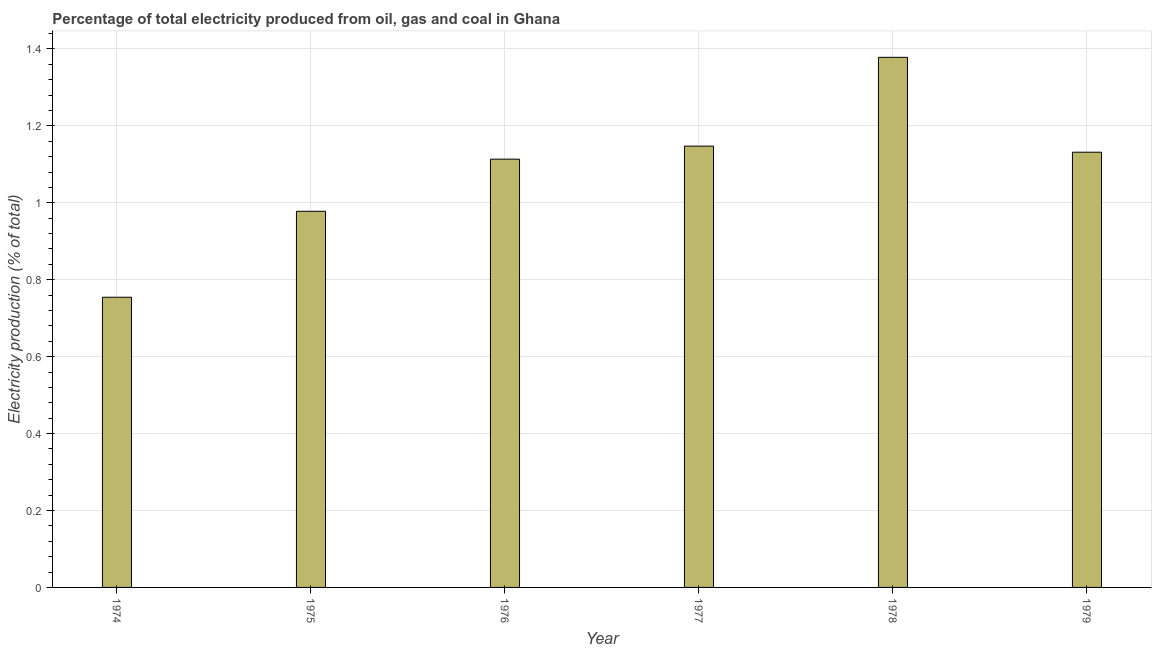What is the title of the graph?
Your response must be concise. Percentage of total electricity produced from oil, gas and coal in Ghana. What is the label or title of the Y-axis?
Your response must be concise. Electricity production (% of total). What is the electricity production in 1979?
Keep it short and to the point. 1.13. Across all years, what is the maximum electricity production?
Provide a short and direct response. 1.38. Across all years, what is the minimum electricity production?
Provide a succinct answer. 0.75. In which year was the electricity production maximum?
Your answer should be very brief. 1978. In which year was the electricity production minimum?
Keep it short and to the point. 1974. What is the sum of the electricity production?
Keep it short and to the point. 6.5. What is the difference between the electricity production in 1975 and 1979?
Give a very brief answer. -0.15. What is the average electricity production per year?
Provide a short and direct response. 1.08. What is the median electricity production?
Provide a succinct answer. 1.12. Do a majority of the years between 1974 and 1979 (inclusive) have electricity production greater than 0.32 %?
Keep it short and to the point. Yes. Is the difference between the electricity production in 1975 and 1976 greater than the difference between any two years?
Your response must be concise. No. What is the difference between the highest and the second highest electricity production?
Your answer should be very brief. 0.23. Is the sum of the electricity production in 1974 and 1975 greater than the maximum electricity production across all years?
Your answer should be very brief. Yes. What is the difference between the highest and the lowest electricity production?
Provide a short and direct response. 0.62. In how many years, is the electricity production greater than the average electricity production taken over all years?
Ensure brevity in your answer.  4. How many bars are there?
Your response must be concise. 6. Are all the bars in the graph horizontal?
Provide a short and direct response. No. How many years are there in the graph?
Your answer should be compact. 6. What is the difference between two consecutive major ticks on the Y-axis?
Make the answer very short. 0.2. What is the Electricity production (% of total) in 1974?
Your answer should be very brief. 0.75. What is the Electricity production (% of total) in 1975?
Your response must be concise. 0.98. What is the Electricity production (% of total) in 1976?
Provide a succinct answer. 1.11. What is the Electricity production (% of total) of 1977?
Make the answer very short. 1.15. What is the Electricity production (% of total) of 1978?
Offer a very short reply. 1.38. What is the Electricity production (% of total) in 1979?
Give a very brief answer. 1.13. What is the difference between the Electricity production (% of total) in 1974 and 1975?
Your answer should be very brief. -0.22. What is the difference between the Electricity production (% of total) in 1974 and 1976?
Offer a terse response. -0.36. What is the difference between the Electricity production (% of total) in 1974 and 1977?
Your answer should be compact. -0.39. What is the difference between the Electricity production (% of total) in 1974 and 1978?
Your answer should be very brief. -0.62. What is the difference between the Electricity production (% of total) in 1974 and 1979?
Provide a succinct answer. -0.38. What is the difference between the Electricity production (% of total) in 1975 and 1976?
Your answer should be very brief. -0.14. What is the difference between the Electricity production (% of total) in 1975 and 1977?
Make the answer very short. -0.17. What is the difference between the Electricity production (% of total) in 1975 and 1978?
Make the answer very short. -0.4. What is the difference between the Electricity production (% of total) in 1975 and 1979?
Keep it short and to the point. -0.15. What is the difference between the Electricity production (% of total) in 1976 and 1977?
Provide a short and direct response. -0.03. What is the difference between the Electricity production (% of total) in 1976 and 1978?
Your answer should be very brief. -0.26. What is the difference between the Electricity production (% of total) in 1976 and 1979?
Keep it short and to the point. -0.02. What is the difference between the Electricity production (% of total) in 1977 and 1978?
Make the answer very short. -0.23. What is the difference between the Electricity production (% of total) in 1977 and 1979?
Ensure brevity in your answer.  0.02. What is the difference between the Electricity production (% of total) in 1978 and 1979?
Provide a short and direct response. 0.25. What is the ratio of the Electricity production (% of total) in 1974 to that in 1975?
Make the answer very short. 0.77. What is the ratio of the Electricity production (% of total) in 1974 to that in 1976?
Provide a short and direct response. 0.68. What is the ratio of the Electricity production (% of total) in 1974 to that in 1977?
Provide a short and direct response. 0.66. What is the ratio of the Electricity production (% of total) in 1974 to that in 1978?
Your answer should be very brief. 0.55. What is the ratio of the Electricity production (% of total) in 1974 to that in 1979?
Offer a very short reply. 0.67. What is the ratio of the Electricity production (% of total) in 1975 to that in 1976?
Your response must be concise. 0.88. What is the ratio of the Electricity production (% of total) in 1975 to that in 1977?
Keep it short and to the point. 0.85. What is the ratio of the Electricity production (% of total) in 1975 to that in 1978?
Your response must be concise. 0.71. What is the ratio of the Electricity production (% of total) in 1975 to that in 1979?
Give a very brief answer. 0.86. What is the ratio of the Electricity production (% of total) in 1976 to that in 1978?
Give a very brief answer. 0.81. What is the ratio of the Electricity production (% of total) in 1976 to that in 1979?
Offer a very short reply. 0.98. What is the ratio of the Electricity production (% of total) in 1977 to that in 1978?
Provide a short and direct response. 0.83. What is the ratio of the Electricity production (% of total) in 1977 to that in 1979?
Provide a succinct answer. 1.01. What is the ratio of the Electricity production (% of total) in 1978 to that in 1979?
Offer a very short reply. 1.22. 